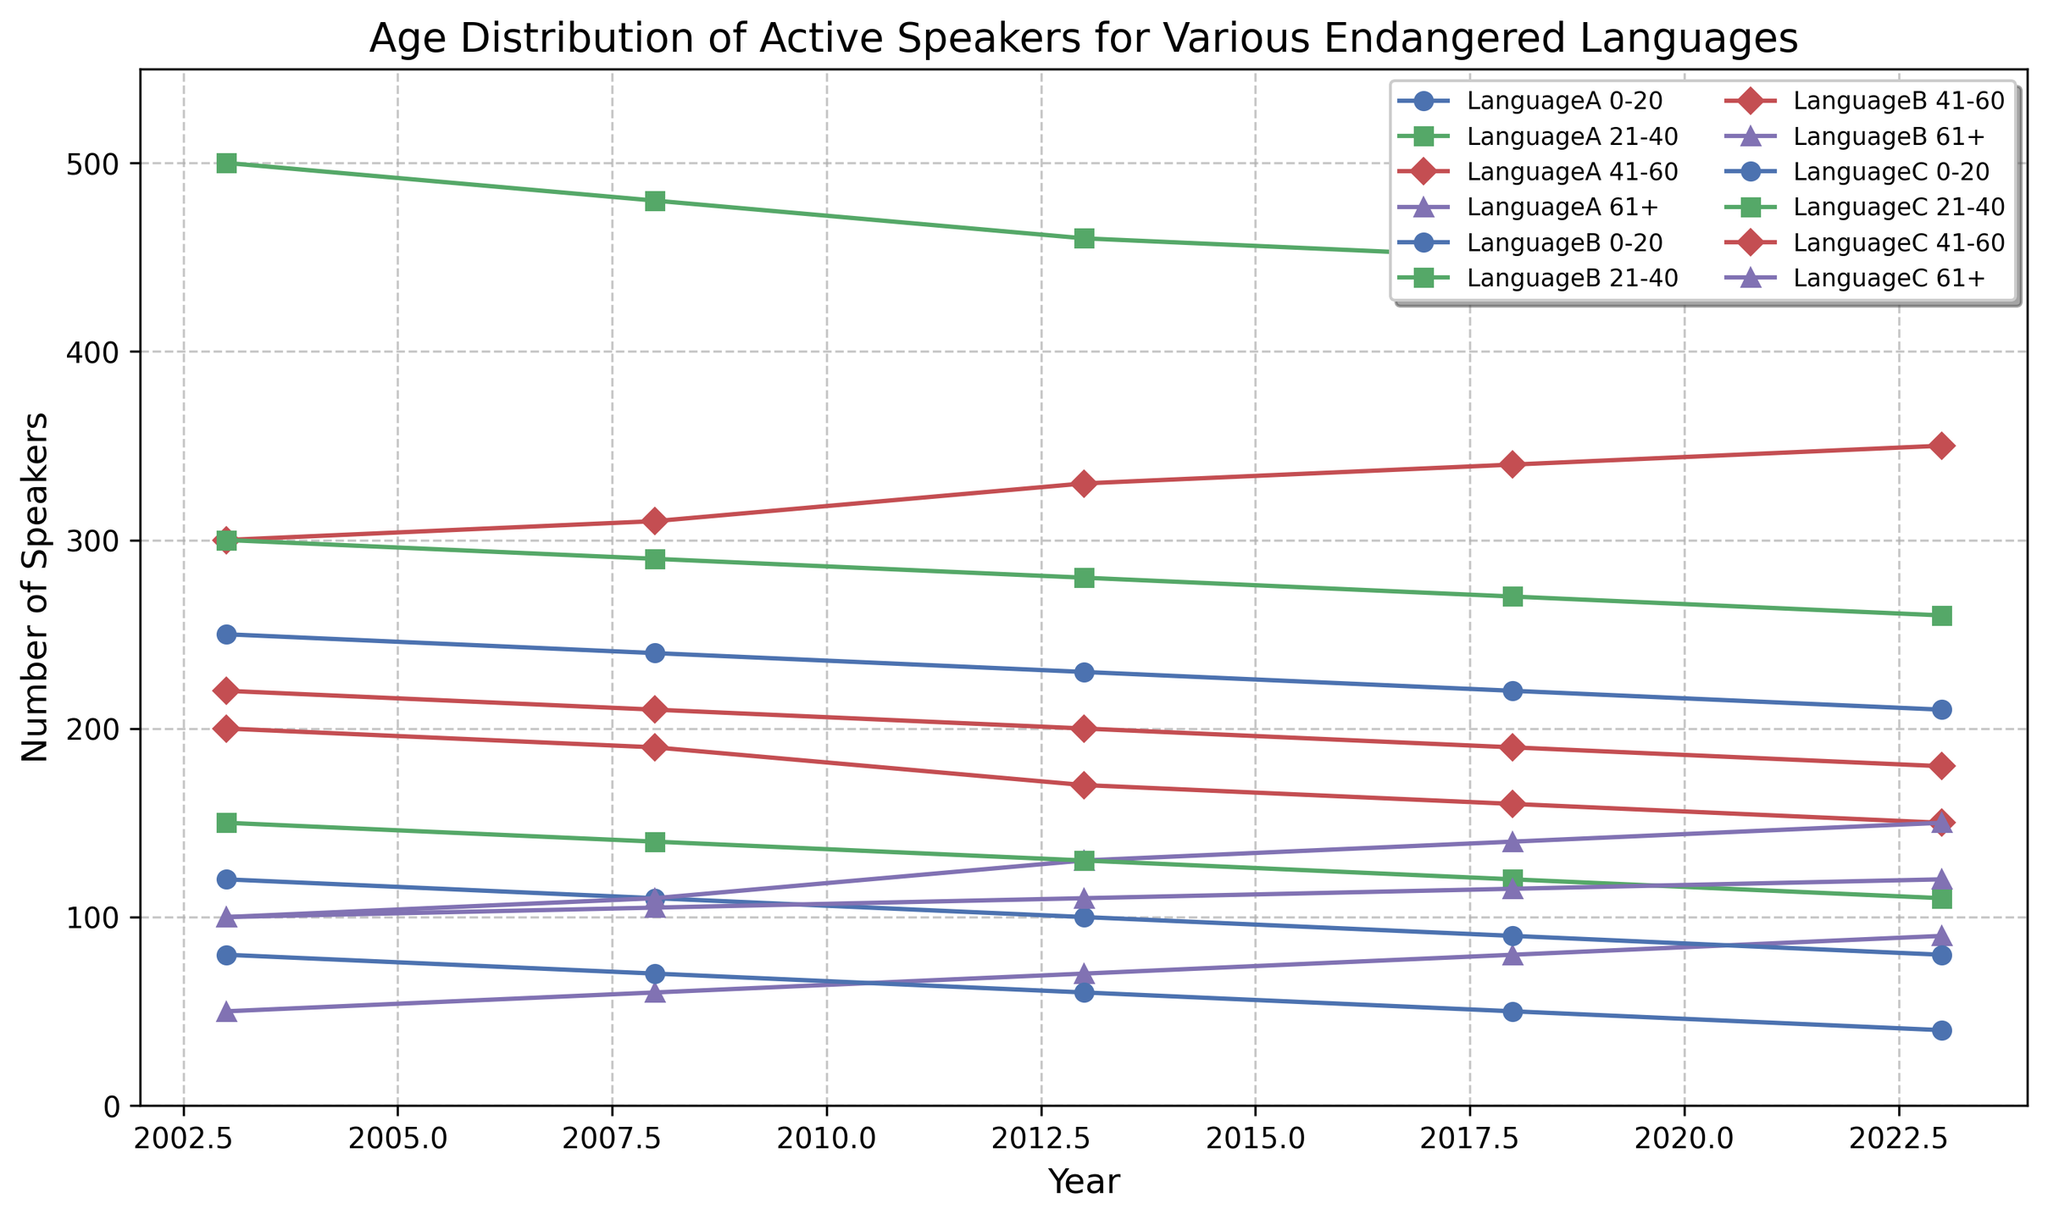What trend can you observe for the number of speakers aged 0-20 for Language A over the 20 years? From the figure, the number of speakers aged 0-20 for Language A shows a decreasing trend. The numbers are 250 in 2003, 240 in 2008, 230 in 2013, 220 in 2018, and 210 in 2023. Therefore, it shows a consistently declining trend over the years.
Answer: Decreasing trend Between Languages A, B, and C, which has the highest number of speakers aged 61+ in 2023? From the figure, the number of speakers aged 61+ in 2023 for Language A is 90, for Language B is 150, and for Language C is 120. Comparing these values, Language B has the highest number of speakers aged 61+ in 2023.
Answer: Language B Which age group saw the most significant increase in the number of speakers for Language C from 2003 to 2023? By examining the trends, we see that the 61+ age group for Language C increased from 100 in 2003 to 120 in 2023. This represents an increase of 20, which is more significant than changes in other age groups for Language C over this period.
Answer: 61+ On average, which age group had the highest number of speakers for Language B over the 20 years? To find the average, sum the number of speakers for each age group across all the years and divide by the number of data points (5 years). For 21-40, the numbers are 300, 290, 280, 270, 260: (300+290+280+270+260)/5 = 280, which is higher than other age groups' averages.
Answer: 21-40 How does the number of speakers aged 41-60 for Language A compare to Language B in 2023? From the figure, in 2023, the number of speakers aged 41-60 for Language A is 350 and for Language B is 150, so Language A has more speakers in this age group.
Answer: Language A has more Which age group and language experienced the largest decline in the number of speakers from 2003 to 2023? The 0-20 age group for Language C experienced a decline from 80 in 2003 to 40 in 2023, a decrease of 40. No other language and age group had a greater decline.
Answer: 0-20, Language C What is the total number of speakers for all age groups combined for Language B in 2008? Add the number of speakers for all age groups for Language B in 2008: 110 (0-20) + 290 (21-40) + 190 (41-60) + 110 (61+). Total = 700.
Answer: 700 Which color line corresponds to the age group 0-20 for all languages in the plot? Based on the figure, the 0-20 age group lines are colored blue for all languages.
Answer: Blue Which language has the smallest total number of speakers in the 0-20 age group in 2023? From the figure, the number of speakers aged 0-20 in 2023 is 210 for Language A, 80 for Language B, and 40 for Language C. Hence, Language C has the smallest total number.
Answer: Language C 